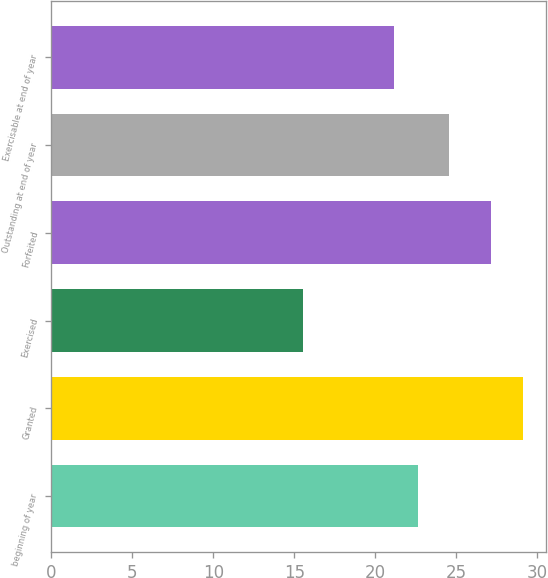Convert chart to OTSL. <chart><loc_0><loc_0><loc_500><loc_500><bar_chart><fcel>beginning of year<fcel>Granted<fcel>Exercised<fcel>Forfeited<fcel>Outstanding at end of year<fcel>Exercisable at end of year<nl><fcel>22.63<fcel>29.11<fcel>15.56<fcel>27.13<fcel>24.58<fcel>21.18<nl></chart> 